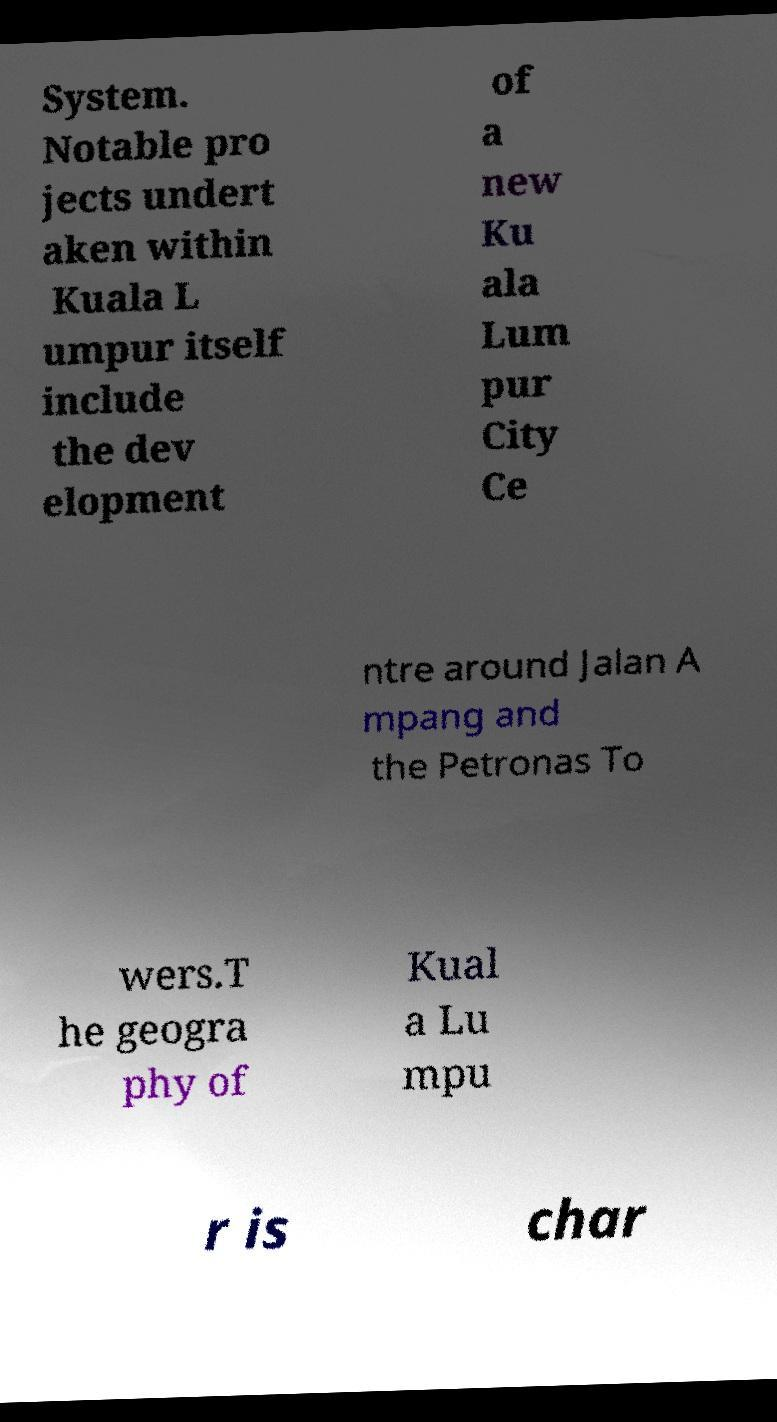What messages or text are displayed in this image? I need them in a readable, typed format. System. Notable pro jects undert aken within Kuala L umpur itself include the dev elopment of a new Ku ala Lum pur City Ce ntre around Jalan A mpang and the Petronas To wers.T he geogra phy of Kual a Lu mpu r is char 